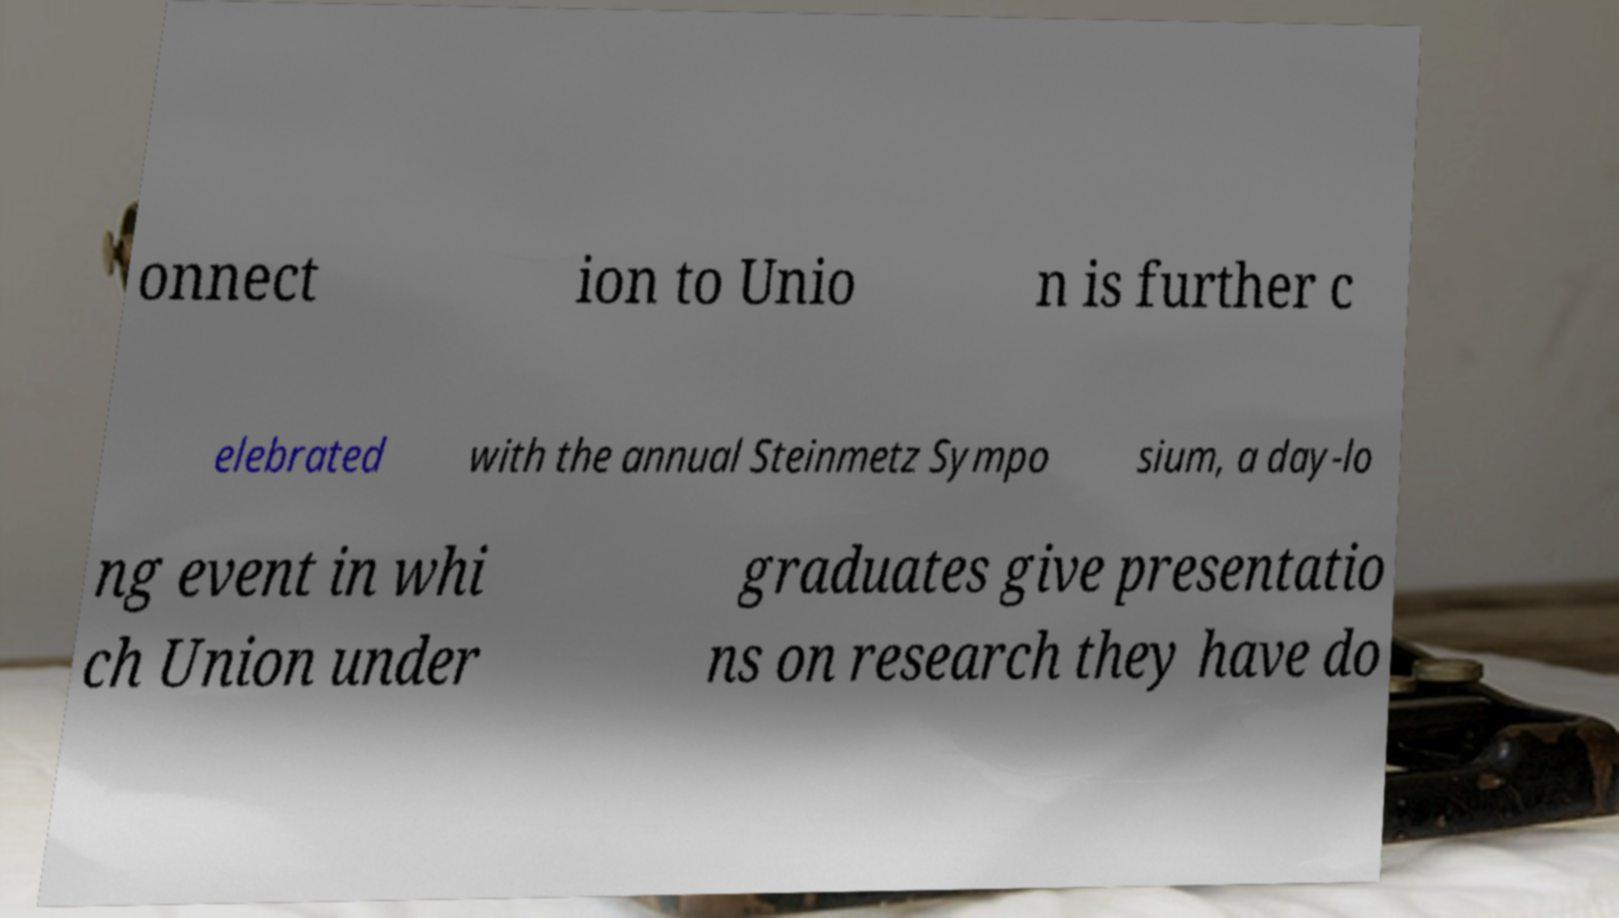Can you read and provide the text displayed in the image?This photo seems to have some interesting text. Can you extract and type it out for me? onnect ion to Unio n is further c elebrated with the annual Steinmetz Sympo sium, a day-lo ng event in whi ch Union under graduates give presentatio ns on research they have do 